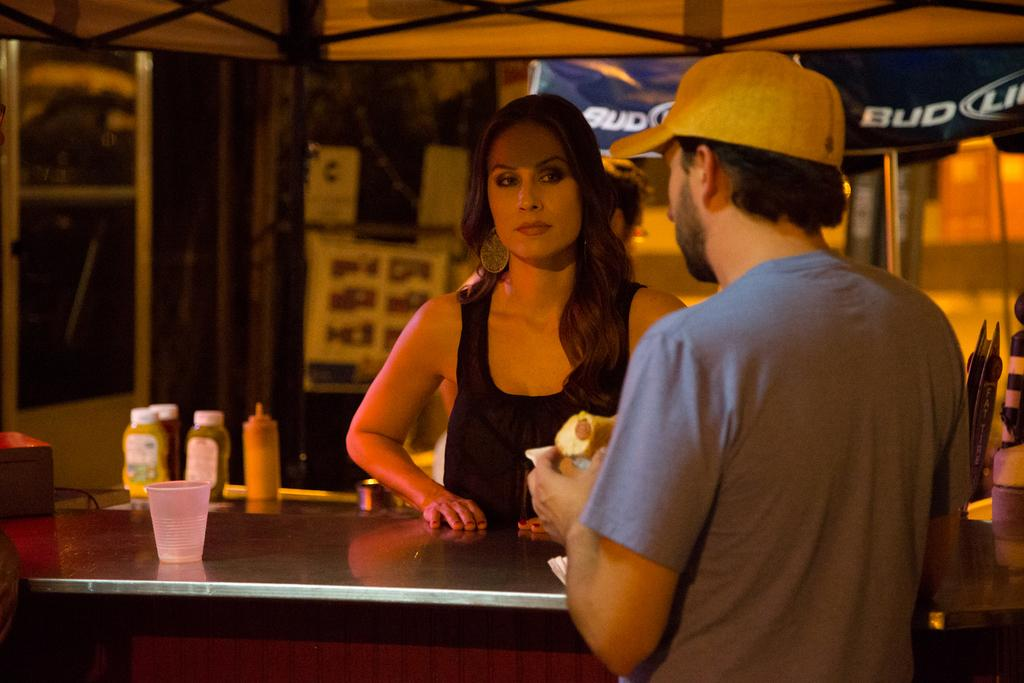How many people are in the image? There are two people in the image, a woman and a man. What are the woman and the man doing in the image? The woman and the man are standing beside a table. What objects can be seen on the table? There are bottles and a glass on the table. What can be used to identify the man in the image? The man is wearing a yellow cap. What architectural feature is visible in the image? The image shows a roof. What arithmetic problem is the woman trying to solve in the image? There is no indication in the image that the woman is trying to solve an arithmetic problem. 